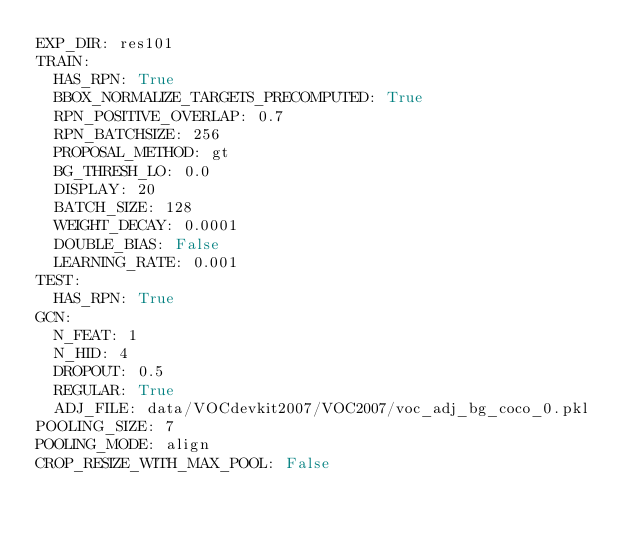<code> <loc_0><loc_0><loc_500><loc_500><_YAML_>EXP_DIR: res101
TRAIN:
  HAS_RPN: True
  BBOX_NORMALIZE_TARGETS_PRECOMPUTED: True
  RPN_POSITIVE_OVERLAP: 0.7
  RPN_BATCHSIZE: 256
  PROPOSAL_METHOD: gt
  BG_THRESH_LO: 0.0
  DISPLAY: 20
  BATCH_SIZE: 128
  WEIGHT_DECAY: 0.0001
  DOUBLE_BIAS: False
  LEARNING_RATE: 0.001
TEST:
  HAS_RPN: True
GCN:
  N_FEAT: 1
  N_HID: 4
  DROPOUT: 0.5
  REGULAR: True
  ADJ_FILE: data/VOCdevkit2007/VOC2007/voc_adj_bg_coco_0.pkl
POOLING_SIZE: 7
POOLING_MODE: align
CROP_RESIZE_WITH_MAX_POOL: False
</code> 